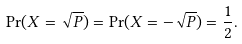Convert formula to latex. <formula><loc_0><loc_0><loc_500><loc_500>\Pr ( X = \sqrt { P } ) = \Pr ( X = - \sqrt { P } ) = \frac { 1 } { 2 } .</formula> 